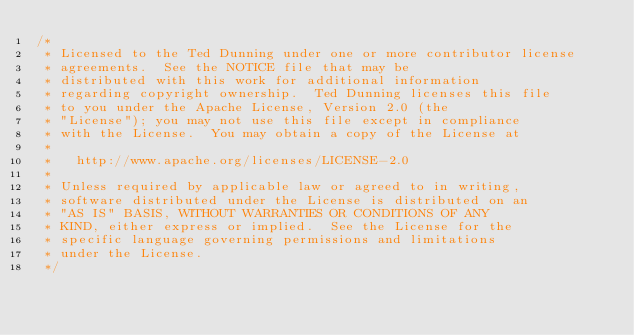Convert code to text. <code><loc_0><loc_0><loc_500><loc_500><_Java_>/*
 * Licensed to the Ted Dunning under one or more contributor license
 * agreements.  See the NOTICE file that may be
 * distributed with this work for additional information
 * regarding copyright ownership.  Ted Dunning licenses this file
 * to you under the Apache License, Version 2.0 (the
 * "License"); you may not use this file except in compliance
 * with the License.  You may obtain a copy of the License at
 *
 *   http://www.apache.org/licenses/LICENSE-2.0
 *
 * Unless required by applicable law or agreed to in writing,
 * software distributed under the License is distributed on an
 * "AS IS" BASIS, WITHOUT WARRANTIES OR CONDITIONS OF ANY
 * KIND, either express or implied.  See the License for the
 * specific language governing permissions and limitations
 * under the License.
 */
</code> 